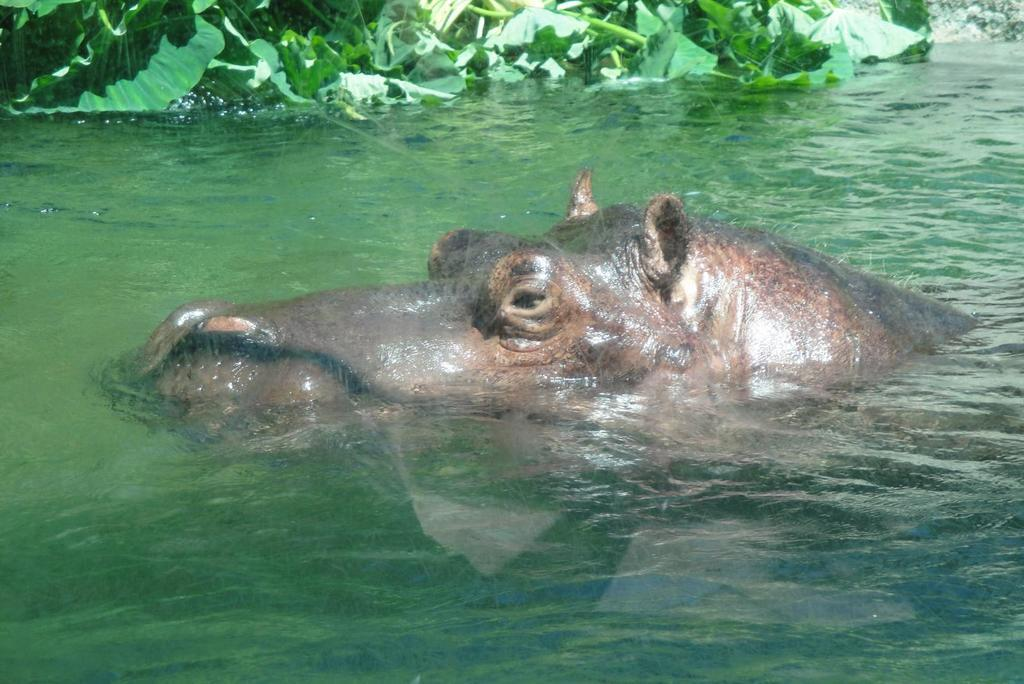What animal is in the water in the image? There is a hippopotamus in the water in the image. What else can be seen in the image besides the hippopotamus? There are plants visible in the image. Which direction is the actor facing in the image? There is no actor present in the image; it features a hippopotamus in the water and plants. Which team is represented by the hippopotamus in the image? The image does not depict a team or any representation of a team; it simply shows a hippopotamus in the water and plants. 